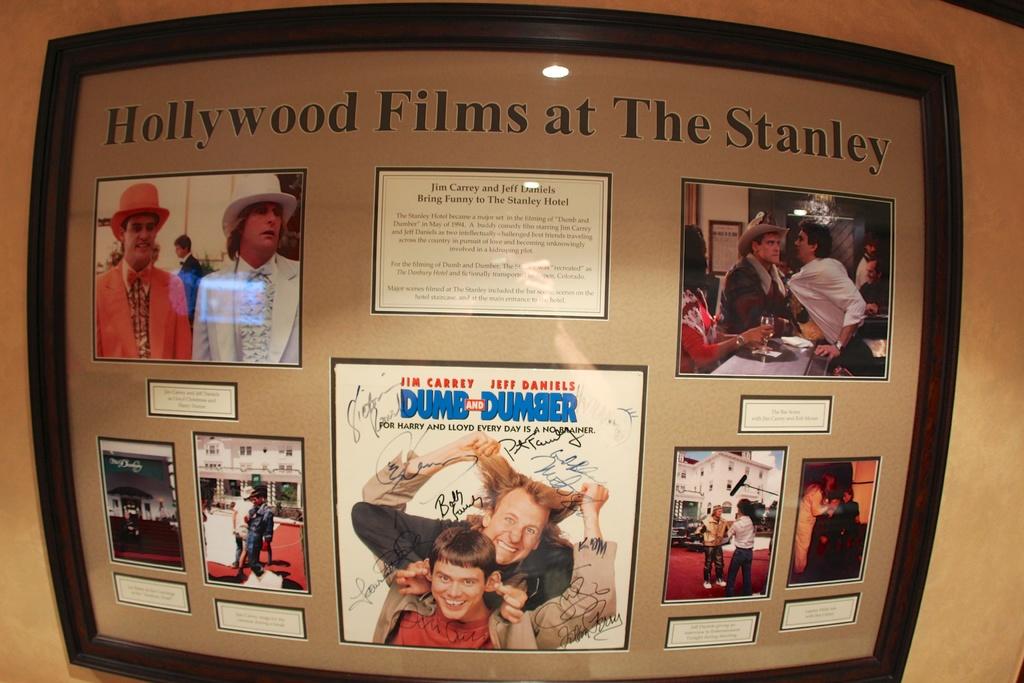Where are these hollywood films?
Give a very brief answer. The stanley. What is the title of the movie in the middle?
Offer a very short reply. Dumb and dumber. 